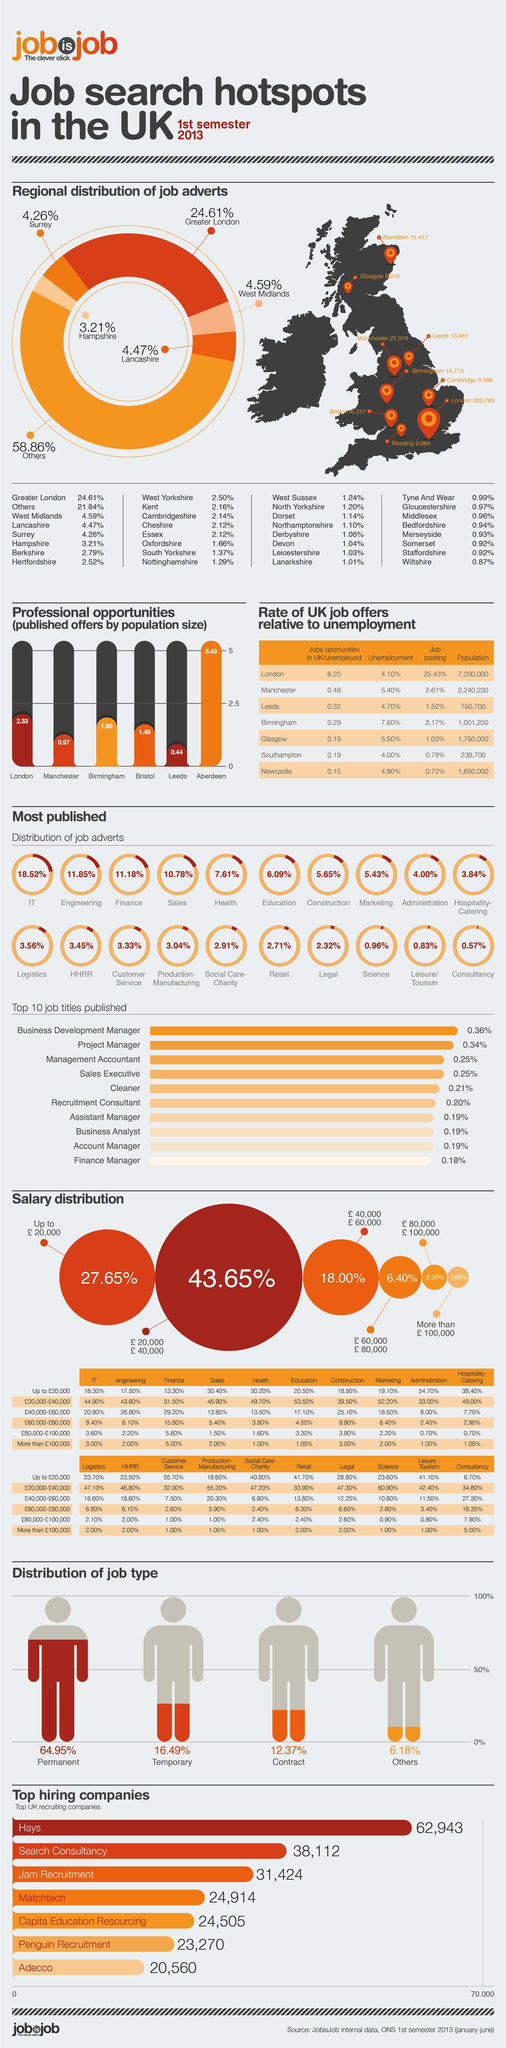Indicate a few pertinent items in this graphic. In 2013, 43.65% of the population in the UK had a salary range of £20,000 to £40,000. London, located in the United Kingdom, has the highest population among all cities in the UK. In 2013, approximately 12.37% of the UK population held contract type of jobs. In 2013, it was estimated that only 1.60% of the UK population had a salary of over £100,000. The unemployment rate in Manchester city in 2013 was 5.40%. 